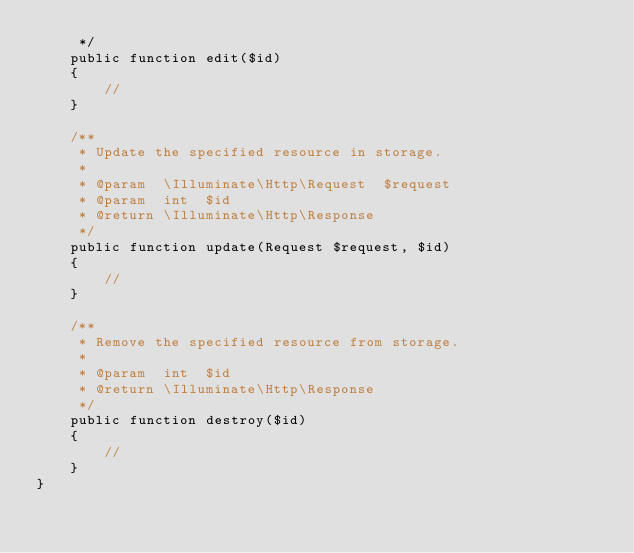<code> <loc_0><loc_0><loc_500><loc_500><_PHP_>     */
    public function edit($id)
    {
        //
    }

    /**
     * Update the specified resource in storage.
     *
     * @param  \Illuminate\Http\Request  $request
     * @param  int  $id
     * @return \Illuminate\Http\Response
     */
    public function update(Request $request, $id)
    {
        //
    }

    /**
     * Remove the specified resource from storage.
     *
     * @param  int  $id
     * @return \Illuminate\Http\Response
     */
    public function destroy($id)
    {
        //
    }
}
</code> 